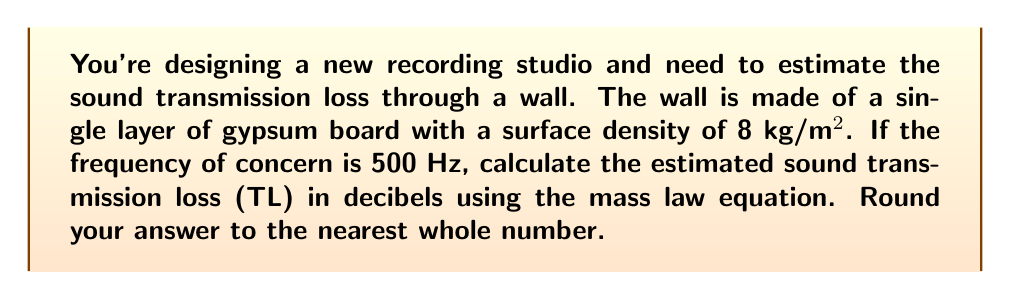What is the answer to this math problem? To solve this problem, we'll use the mass law equation for sound transmission loss:

$$TL = 20\log_{10}(fm) - 47$$

Where:
$TL$ = Sound Transmission Loss (dB)
$f$ = Frequency (Hz)
$m$ = Surface density of the wall (kg/m²)

Given:
$f = 500$ Hz
$m = 8$ kg/m²

Let's substitute these values into the equation:

$$TL = 20\log_{10}(500 \times 8) - 47$$

$$TL = 20\log_{10}(4000) - 47$$

Now, let's calculate:

$$TL = 20 \times 3.6020599913 - 47$$

$$TL = 72.0411998260 - 47$$

$$TL = 25.0411998260$$

Rounding to the nearest whole number:

$$TL \approx 25 \text{ dB}$$

This result indicates that the single layer of gypsum board will reduce sound transmission by approximately 25 decibels at 500 Hz.
Answer: 25 dB 